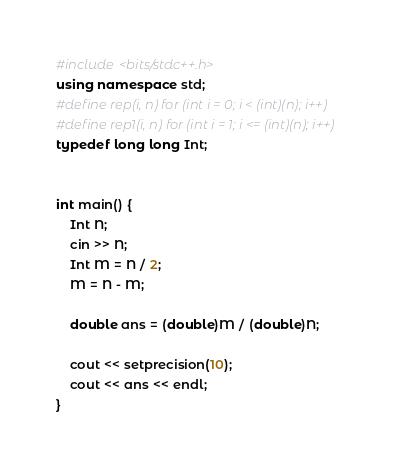Convert code to text. <code><loc_0><loc_0><loc_500><loc_500><_C++_>#include <bits/stdc++.h>
using namespace std;
#define rep(i, n) for (int i = 0; i < (int)(n); i++)
#define rep1(i, n) for (int i = 1; i <= (int)(n); i++)
typedef long long Int;


int main() {
    Int N;
    cin >> N;
    Int M = N / 2;
    M = N - M;
  
    double ans = (double)M / (double)N;
  
    cout << setprecision(10);
    cout << ans << endl;
}</code> 